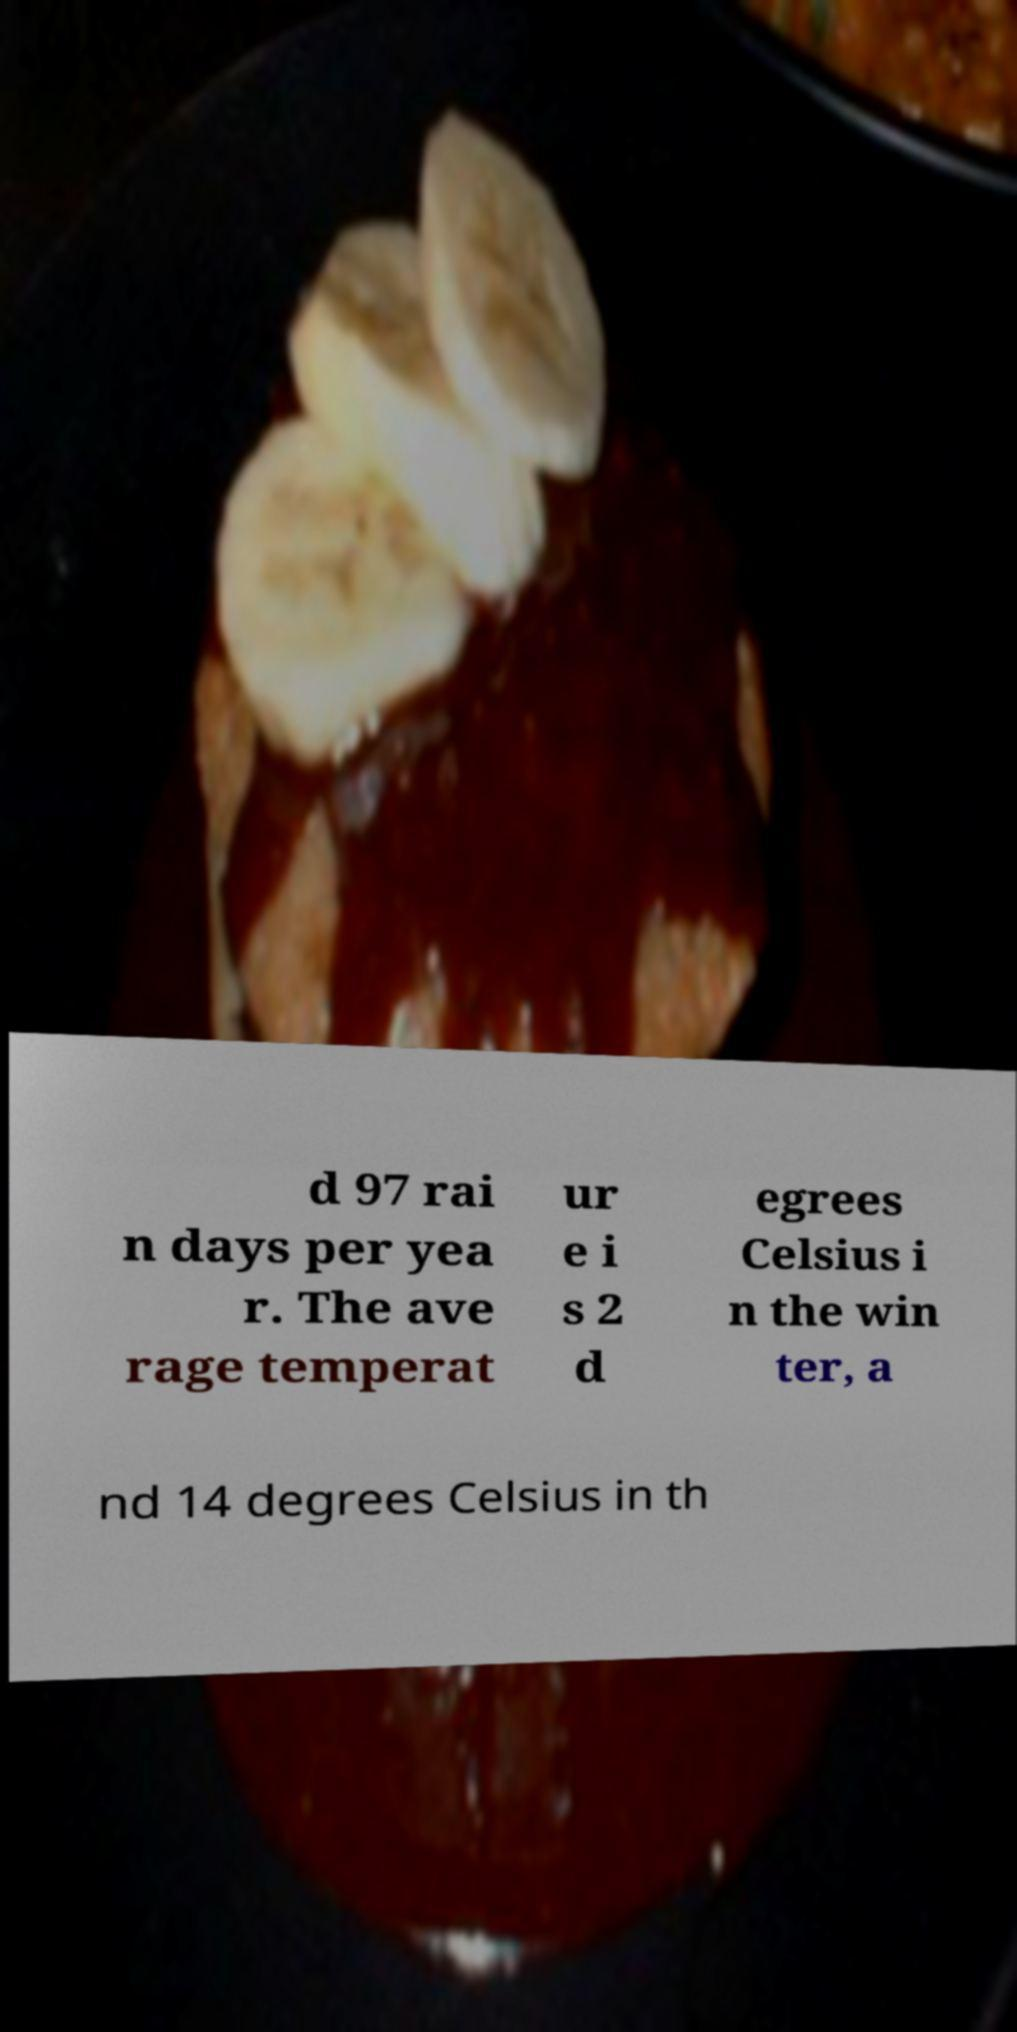Please read and relay the text visible in this image. What does it say? d 97 rai n days per yea r. The ave rage temperat ur e i s 2 d egrees Celsius i n the win ter, a nd 14 degrees Celsius in th 